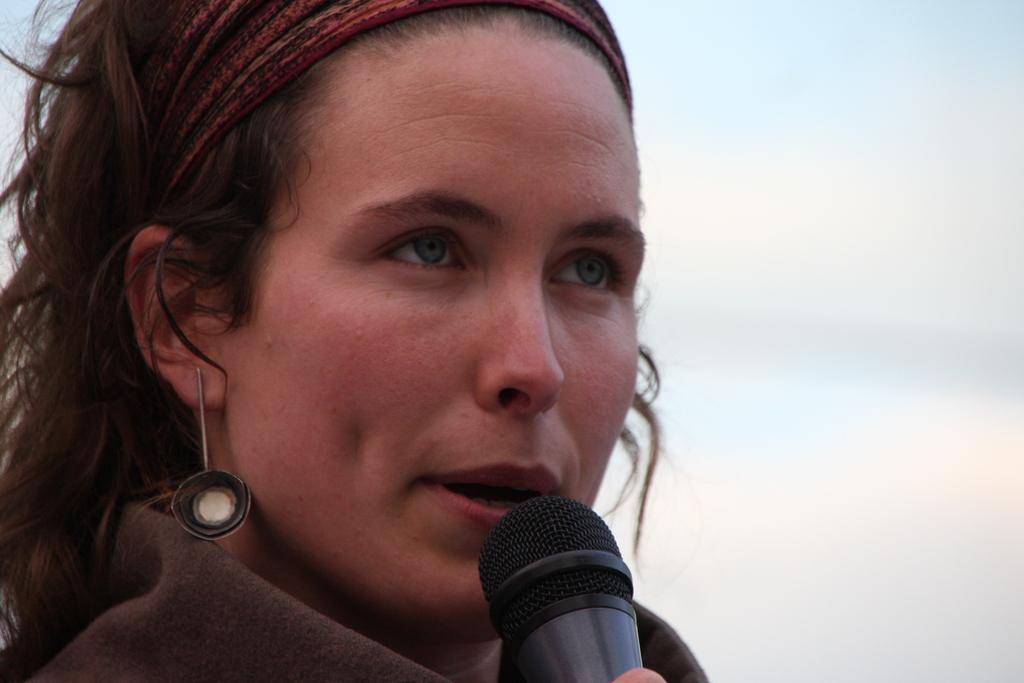Who is the main subject in the image? There is a lady in the image. What accessories is the lady wearing? The lady is wearing beautiful earrings and a hairband. What is the lady holding in her hand? The lady is holding a microphone in her hand. What can be observed about the lady's eyes? The lady has beautiful blue eyes. What type of drink is the lady holding in the image? There is no drink visible in the image; the lady is holding a microphone. What kind of jewel is the lady wearing on her neck? There is no mention of a necklace or any other type of jewel in the provided facts. 